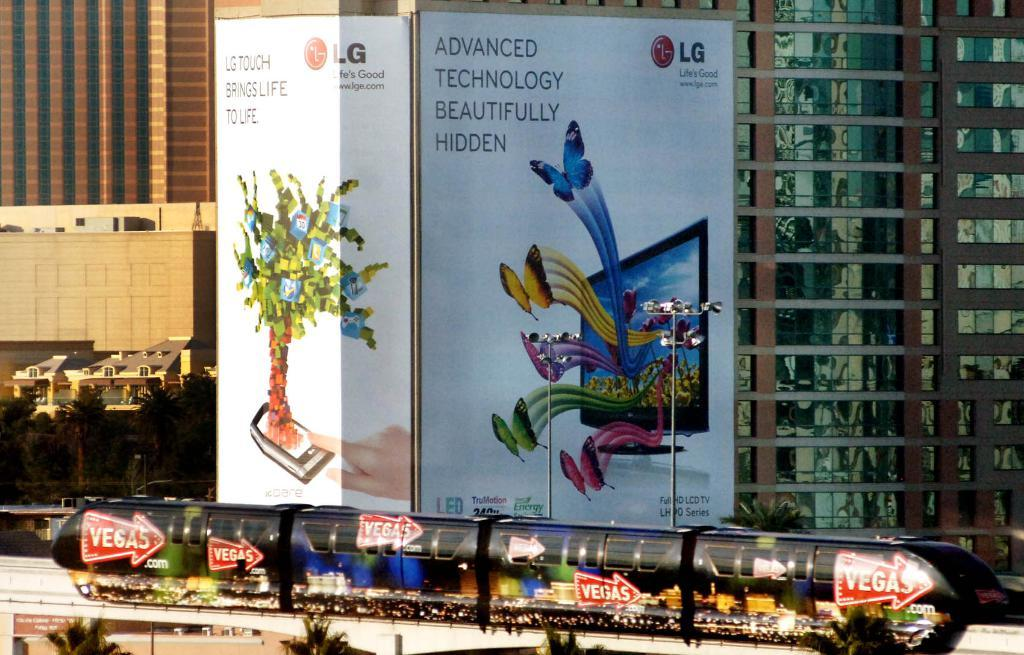<image>
Provide a brief description of the given image. A huge sign on a building says advanced technology beautifully hidden. 